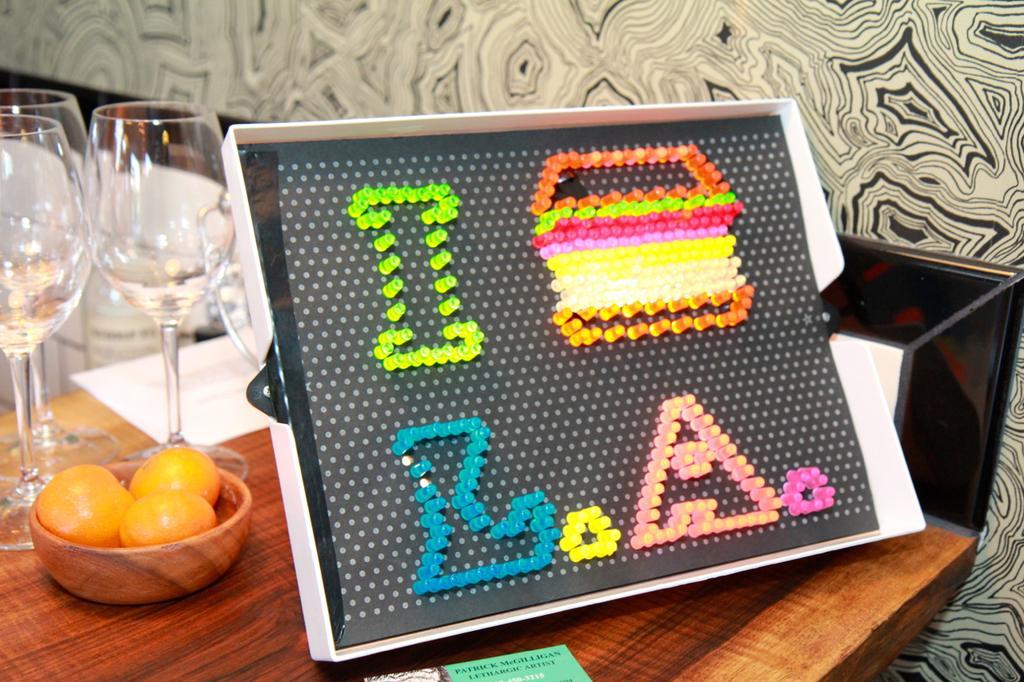In one or two sentences, can you explain what this image depicts? In this image in the front there is a board with some text written on it and there are glasses, fruits and there are papers on the table. In the background there is a wall and on the wall there is a painting. 